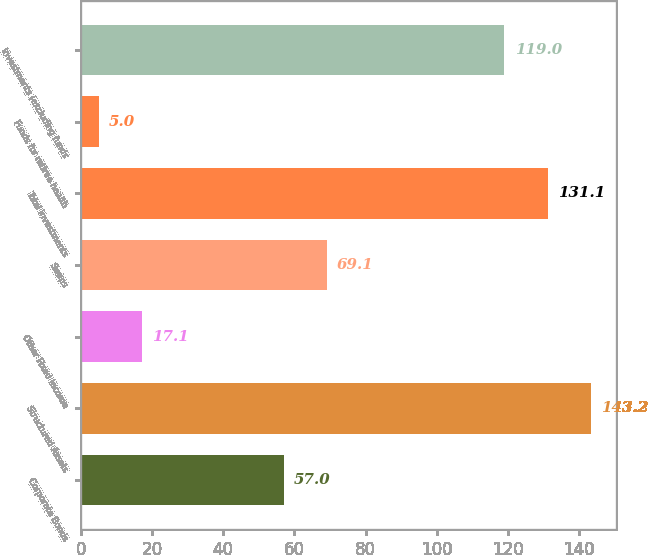Convert chart to OTSL. <chart><loc_0><loc_0><loc_500><loc_500><bar_chart><fcel>Corporate Bonds<fcel>Structured Assets<fcel>Other Fixed Income<fcel>Swaps<fcel>Total investments<fcel>Funds for retiree health<fcel>Investments (excluding funds<nl><fcel>57<fcel>143.2<fcel>17.1<fcel>69.1<fcel>131.1<fcel>5<fcel>119<nl></chart> 